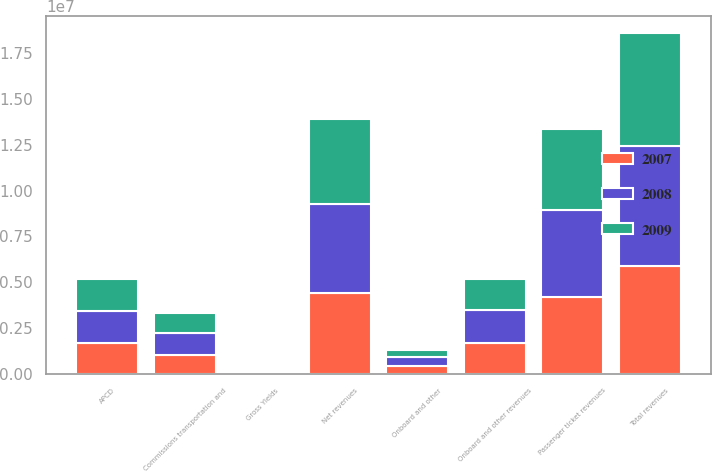Convert chart. <chart><loc_0><loc_0><loc_500><loc_500><stacked_bar_chart><ecel><fcel>Passenger ticket revenues<fcel>Onboard and other revenues<fcel>Total revenues<fcel>Commissions transportation and<fcel>Onboard and other<fcel>Net revenues<fcel>APCD<fcel>Gross Yields<nl><fcel>2007<fcel>4.20571e+06<fcel>1.68412e+06<fcel>5.88983e+06<fcel>1.02887e+06<fcel>457772<fcel>4.40319e+06<fcel>1.72176e+06<fcel>211.7<nl><fcel>2008<fcel>4.73029e+06<fcel>1.80224e+06<fcel>6.53252e+06<fcel>1.19232e+06<fcel>458385<fcel>4.88182e+06<fcel>1.72176e+06<fcel>246.85<nl><fcel>2009<fcel>4.42738e+06<fcel>1.72176e+06<fcel>6.14914e+06<fcel>1.12402e+06<fcel>405637<fcel>4.61948e+06<fcel>1.72176e+06<fcel>244.44<nl></chart> 